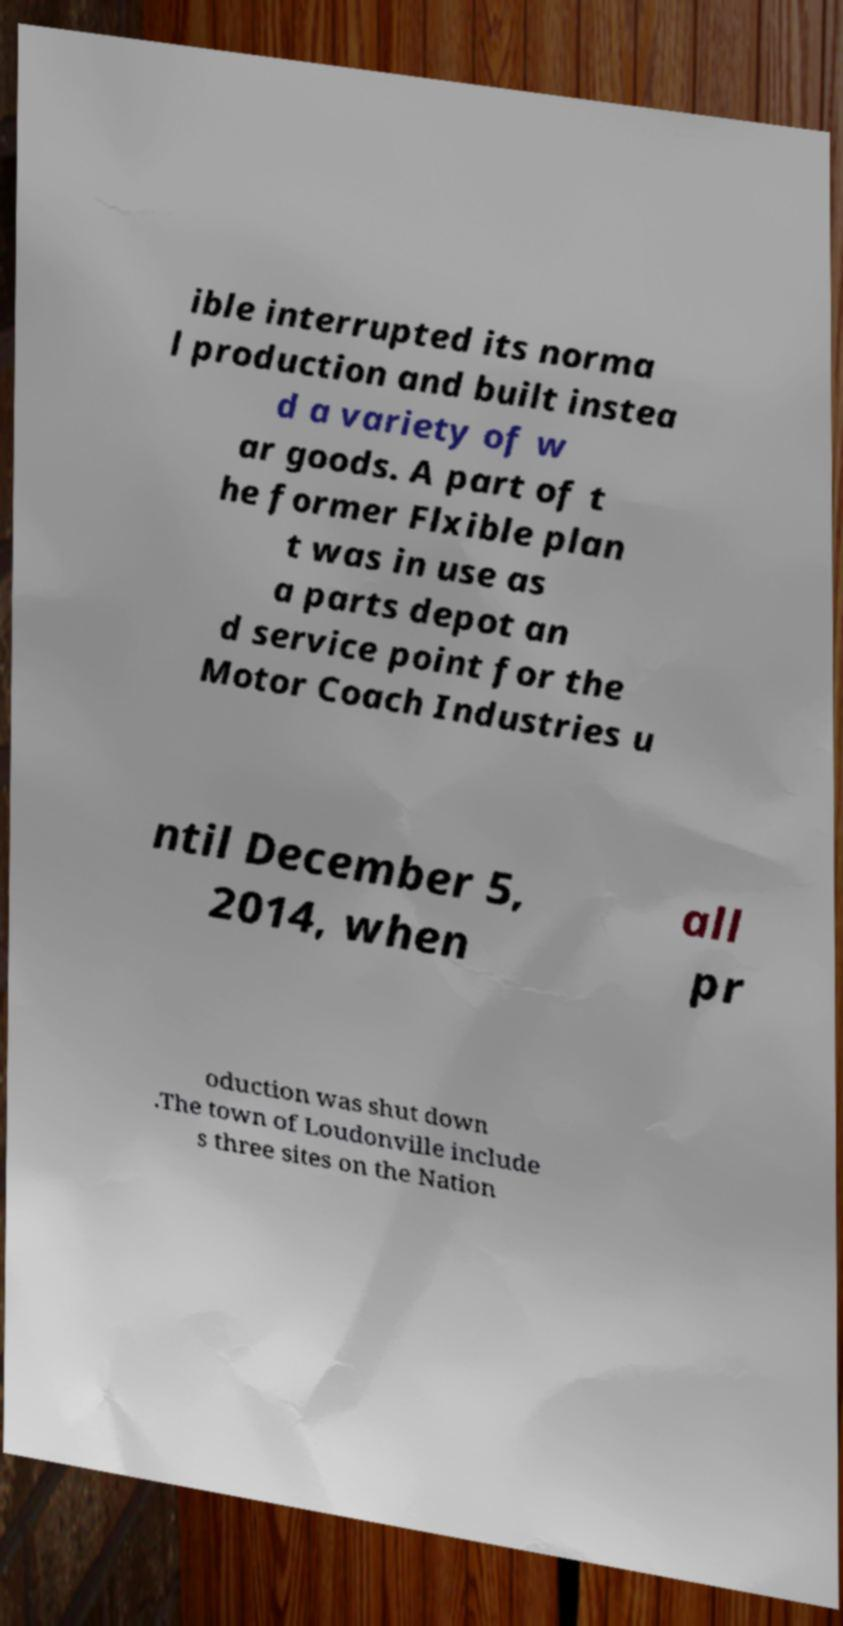Please read and relay the text visible in this image. What does it say? ible interrupted its norma l production and built instea d a variety of w ar goods. A part of t he former Flxible plan t was in use as a parts depot an d service point for the Motor Coach Industries u ntil December 5, 2014, when all pr oduction was shut down .The town of Loudonville include s three sites on the Nation 